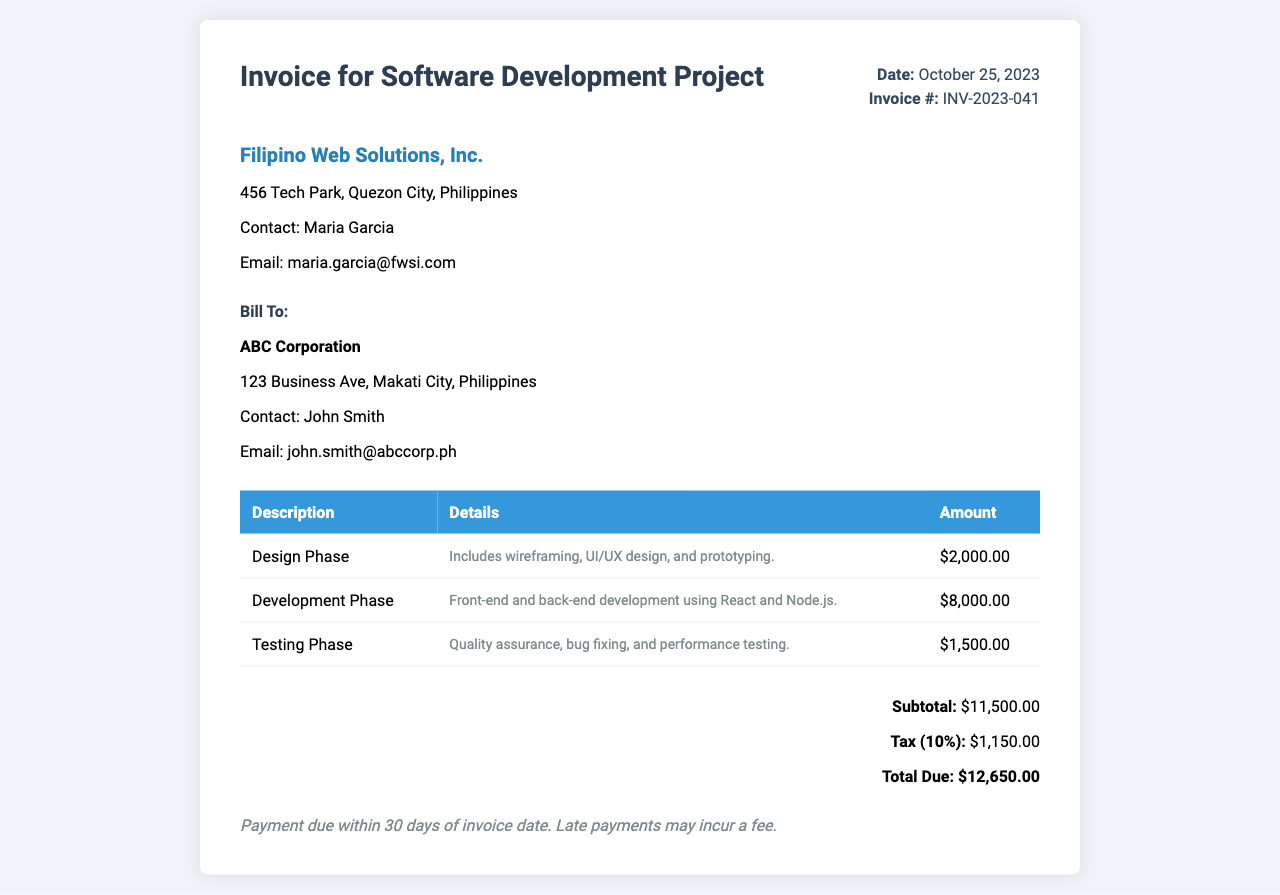what is the invoice date? The invoice date is clearly listed in the invoice details.
Answer: October 25, 2023 what is the invoice number? The invoice number is specified in the invoice details section.
Answer: INV-2023-041 who is the contact person from Filipino Web Solutions, Inc.? The contact person is identified in the company details section of the invoice.
Answer: Maria Garcia what is the total amount due? The total amount due is calculated from the subtotal and tax in the total section of the invoice.
Answer: $12,650.00 what is the amount for the Development Phase? The amount for the Development Phase is specified in the itemized table.
Answer: $8,000.00 how much is the tax percentage applied? The tax percentage is indicated in the total section of the invoice.
Answer: 10% what is included in the Testing Phase? The details of the Testing Phase are described in the itemized table under the respective entry.
Answer: Quality assurance, bug fixing, and performance testing who is billed in this invoice? The billing information is presented under the "Bill To" section of the invoice.
Answer: ABC Corporation when is the payment due? The payment terms specify the timeframe within which payment should be made.
Answer: Within 30 days of invoice date 